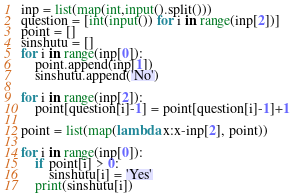Convert code to text. <code><loc_0><loc_0><loc_500><loc_500><_Python_>inp = list(map(int,input().split()))
question = [int(input()) for i in range(inp[2])]
point = []
sinshutu = []
for i in range(inp[0]):
    point.append(inp[1])
    sinshutu.append('No')

for i in range(inp[2]):
    point[question[i]-1] = point[question[i]-1]+1

point = list(map(lambda x:x-inp[2], point))

for i in range(inp[0]):
    if point[i] > 0:
        sinshutu[i] = 'Yes'
    print(sinshutu[i])</code> 